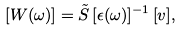<formula> <loc_0><loc_0><loc_500><loc_500>[ W ( \omega ) ] = \tilde { S } \, [ \epsilon ( \omega ) ] ^ { - 1 } \, [ v ] ,</formula> 